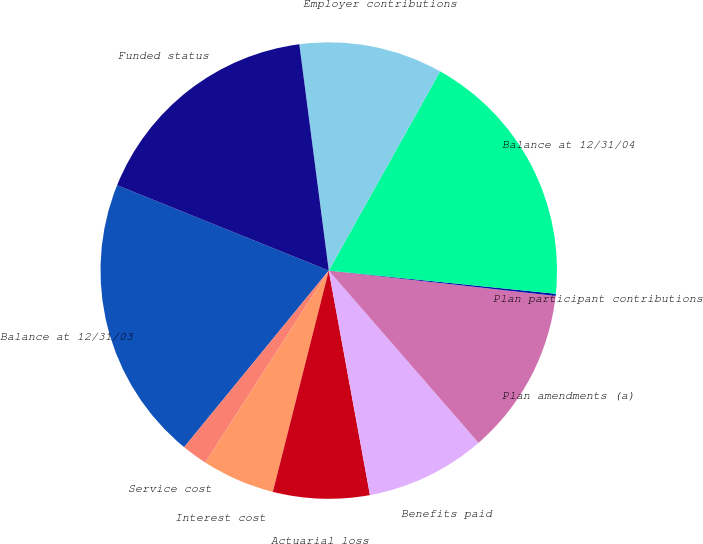Convert chart. <chart><loc_0><loc_0><loc_500><loc_500><pie_chart><fcel>Balance at 12/31/03<fcel>Service cost<fcel>Interest cost<fcel>Actuarial loss<fcel>Benefits paid<fcel>Plan amendments (a)<fcel>Plan participant contributions<fcel>Balance at 12/31/04<fcel>Employer contributions<fcel>Funded status<nl><fcel>20.18%<fcel>1.82%<fcel>5.16%<fcel>6.83%<fcel>8.5%<fcel>11.84%<fcel>0.15%<fcel>18.51%<fcel>10.17%<fcel>16.84%<nl></chart> 